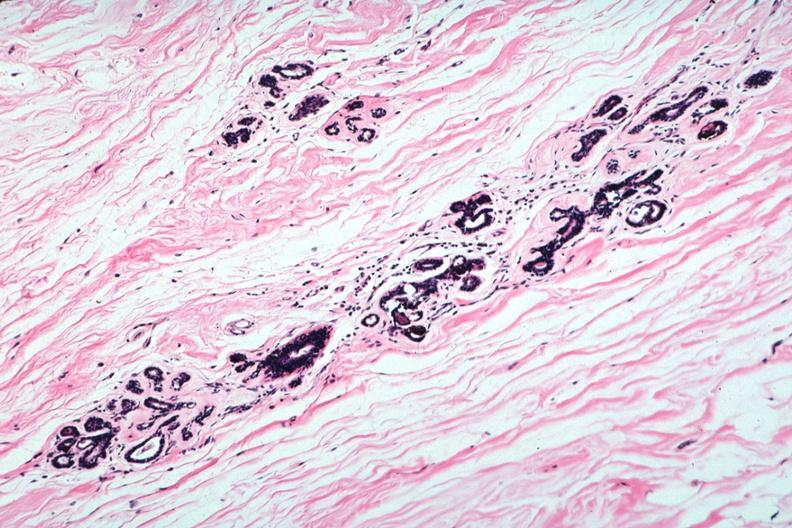s acute lymphocytic leukemia present?
Answer the question using a single word or phrase. No 